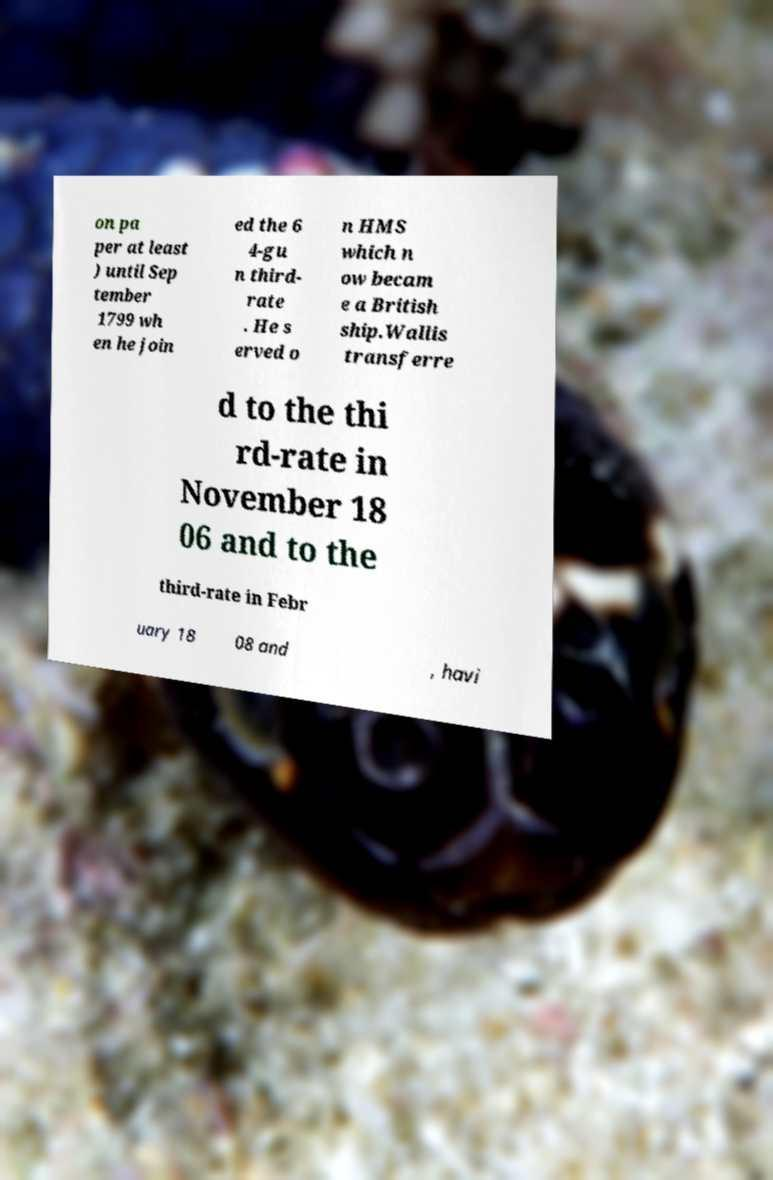For documentation purposes, I need the text within this image transcribed. Could you provide that? on pa per at least ) until Sep tember 1799 wh en he join ed the 6 4-gu n third- rate . He s erved o n HMS which n ow becam e a British ship.Wallis transferre d to the thi rd-rate in November 18 06 and to the third-rate in Febr uary 18 08 and , havi 